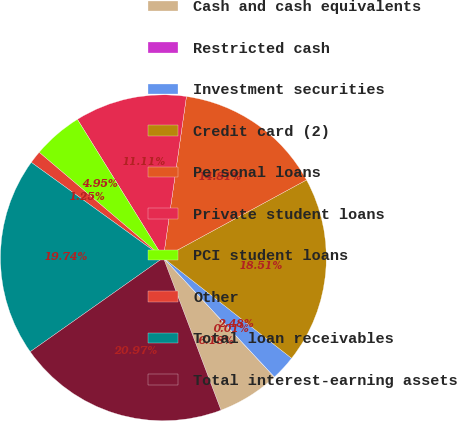<chart> <loc_0><loc_0><loc_500><loc_500><pie_chart><fcel>Cash and cash equivalents<fcel>Restricted cash<fcel>Investment securities<fcel>Credit card (2)<fcel>Personal loans<fcel>Private student loans<fcel>PCI student loans<fcel>Other<fcel>Total loan receivables<fcel>Total interest-earning assets<nl><fcel>6.18%<fcel>0.01%<fcel>2.48%<fcel>18.51%<fcel>14.81%<fcel>11.11%<fcel>4.95%<fcel>1.25%<fcel>19.74%<fcel>20.97%<nl></chart> 